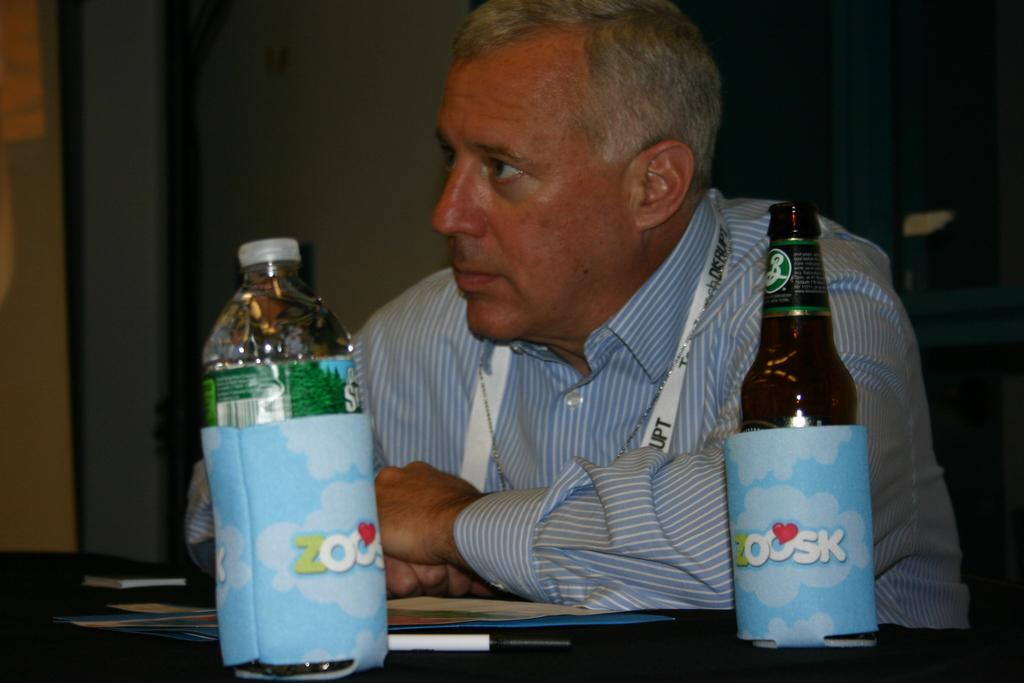Who is present in the image? There is a man in the image. What is the man doing in the image? The man is sitting on a chair. What is in front of the man? There is a table in front of the man. What items can be seen on the table? There are two bottles, books, and pens on the table. Can you see any boats in the harbor in the image? There is no harbor or boats present in the image; it features a man sitting on a chair with a table in front of him. What type of bird is perched on the can in the image? There is no bird or can present in the image. 